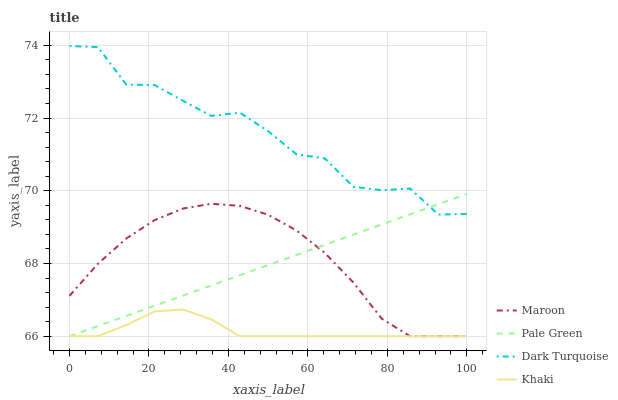Does Khaki have the minimum area under the curve?
Answer yes or no. Yes. Does Dark Turquoise have the maximum area under the curve?
Answer yes or no. Yes. Does Pale Green have the minimum area under the curve?
Answer yes or no. No. Does Pale Green have the maximum area under the curve?
Answer yes or no. No. Is Pale Green the smoothest?
Answer yes or no. Yes. Is Dark Turquoise the roughest?
Answer yes or no. Yes. Is Khaki the smoothest?
Answer yes or no. No. Is Khaki the roughest?
Answer yes or no. No. Does Pale Green have the lowest value?
Answer yes or no. Yes. Does Dark Turquoise have the highest value?
Answer yes or no. Yes. Does Pale Green have the highest value?
Answer yes or no. No. Is Khaki less than Dark Turquoise?
Answer yes or no. Yes. Is Dark Turquoise greater than Khaki?
Answer yes or no. Yes. Does Pale Green intersect Maroon?
Answer yes or no. Yes. Is Pale Green less than Maroon?
Answer yes or no. No. Is Pale Green greater than Maroon?
Answer yes or no. No. Does Khaki intersect Dark Turquoise?
Answer yes or no. No. 